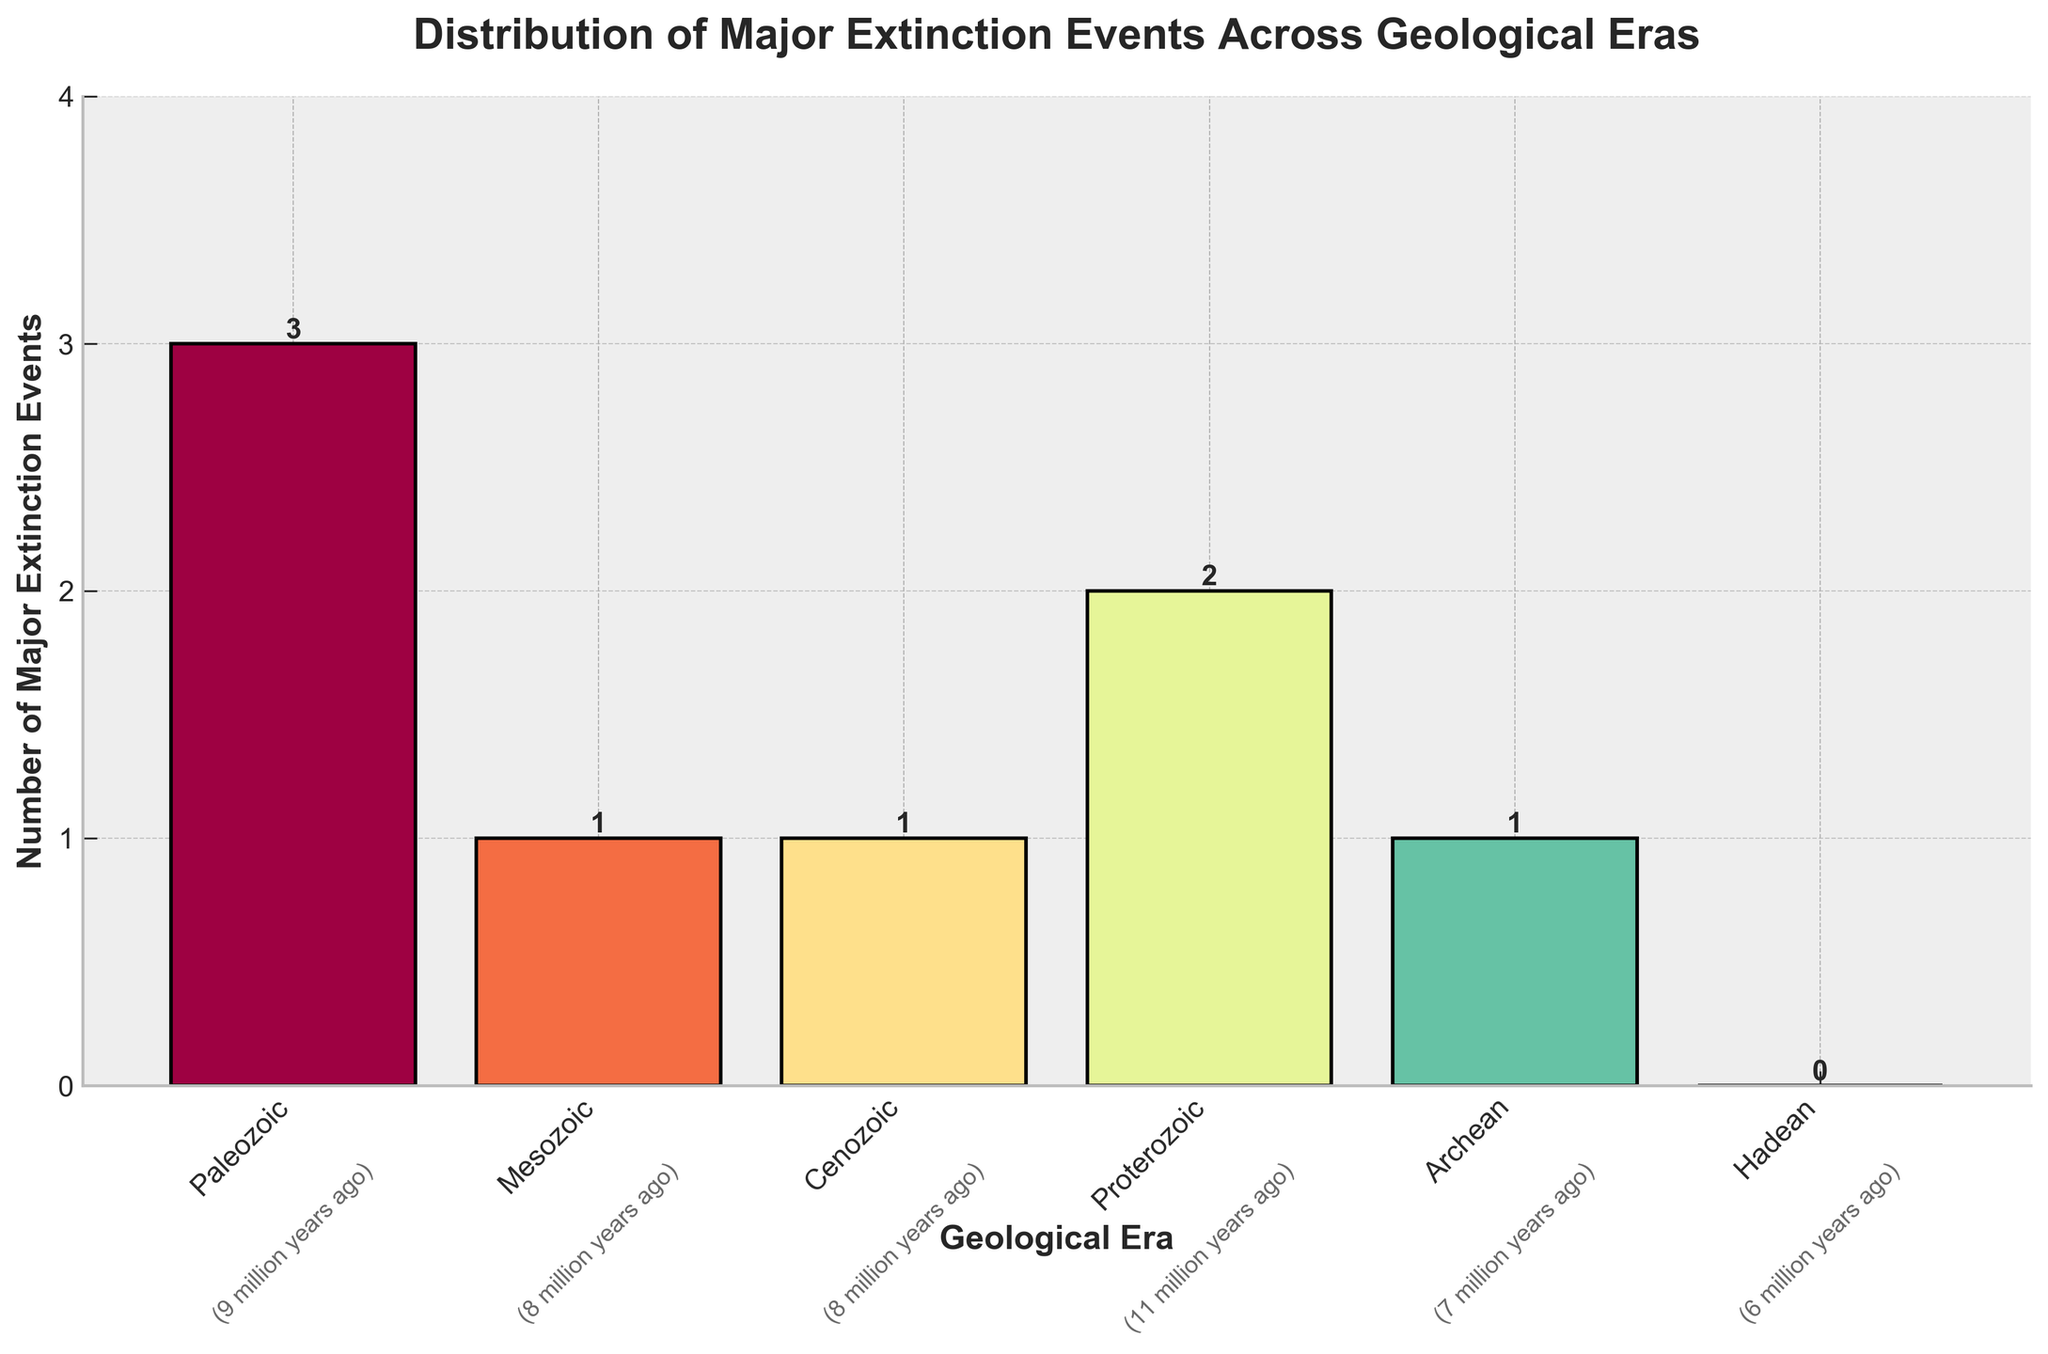What is the total number of major extinction events displayed in the figure? Sum up all the major extinction events from each era: Paleozoic (3) + Mesozoic (1) + Cenozoic (1) + Proterozoic (2) + Archean (1) + Hadean (0). The total is 3+1+1+2+1+0.
Answer: 8 Which geological era has the highest number of major extinction events? Look at the heights of the bars and identify the bar that is the tallest. The Paleozoic era has the tallest bar indicating it has the highest number of major extinction events.
Answer: Paleozoic How many eras have two or more major extinction events? Identify the bars with a height of 2 or more and count them. The Paleozoic era (3) and Proterozoic era (2) both meet this criterion.
Answer: 2 Calculate the average number of major extinction events across all geological eras. Sum the number of major extinction events (8) and divide by the number of eras (6): 8 / 6.
Answer: 1.33 Compare the number of major extinction events in the Paleozoic era to the Cenozoic era. Which one is greater and by how much? Find the difference between the number of major extinction events in the Paleozoic era (3) and the Cenozoic era (1): 3 - 1.
Answer: Paleozoic by 2 Which geological era experienced no major extinction events? Look for the bar with no height. The Hadean era has a height of 0, indicating no major extinction events.
Answer: Hadean Is the number of major extinction events in the Mesozoic era greater than zero? Check the height of the bar for the Mesozoic era. The bar has a height of 1, which is greater than zero.
Answer: Yes If the Archean era had one additional major extinction event, how many eras would then have two or more events? Adding one extinction event to the Archean era would make it have 2 major extinction events. Now, Paleozoic, Proterozoic, and Archean will each have 2 or more events.
Answer: 3 By how much does the number of major extinction events in the Proterozoic era differ from the Archean era? Subtract the number of events in the Archean era (1) from those in the Proterozoic era (2): 2 - 1.
Answer: 1 